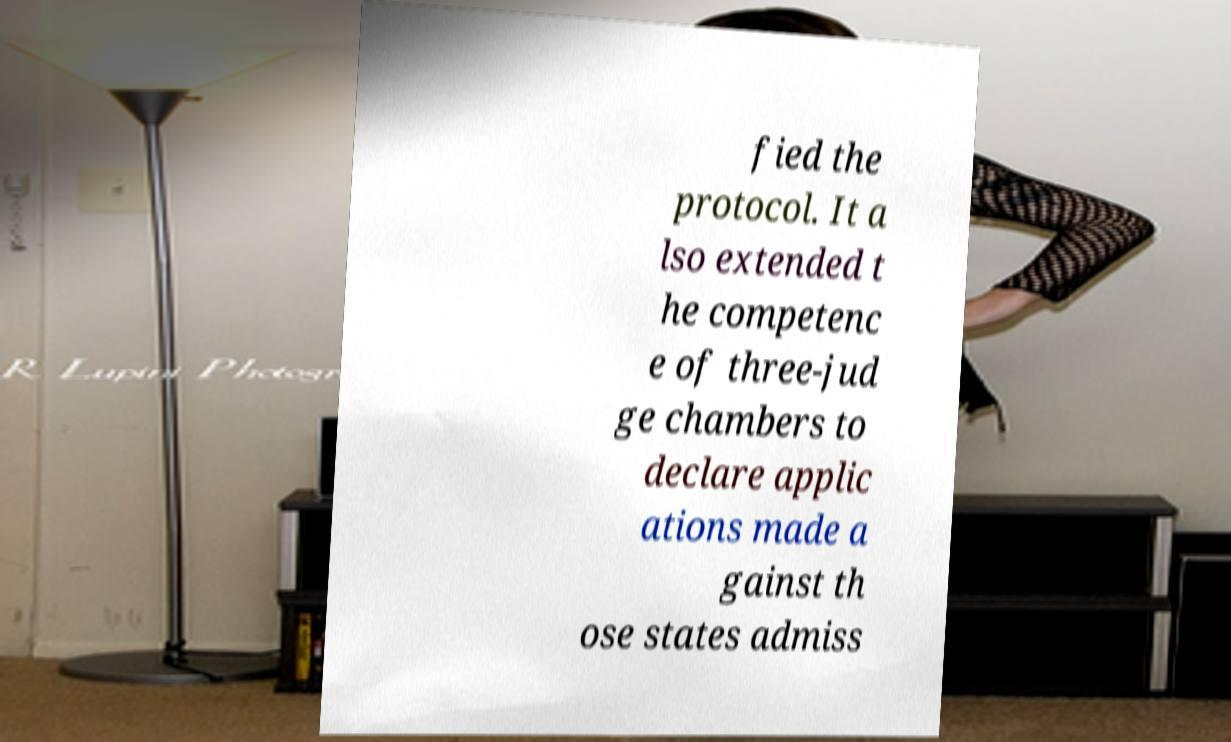Can you accurately transcribe the text from the provided image for me? fied the protocol. It a lso extended t he competenc e of three-jud ge chambers to declare applic ations made a gainst th ose states admiss 